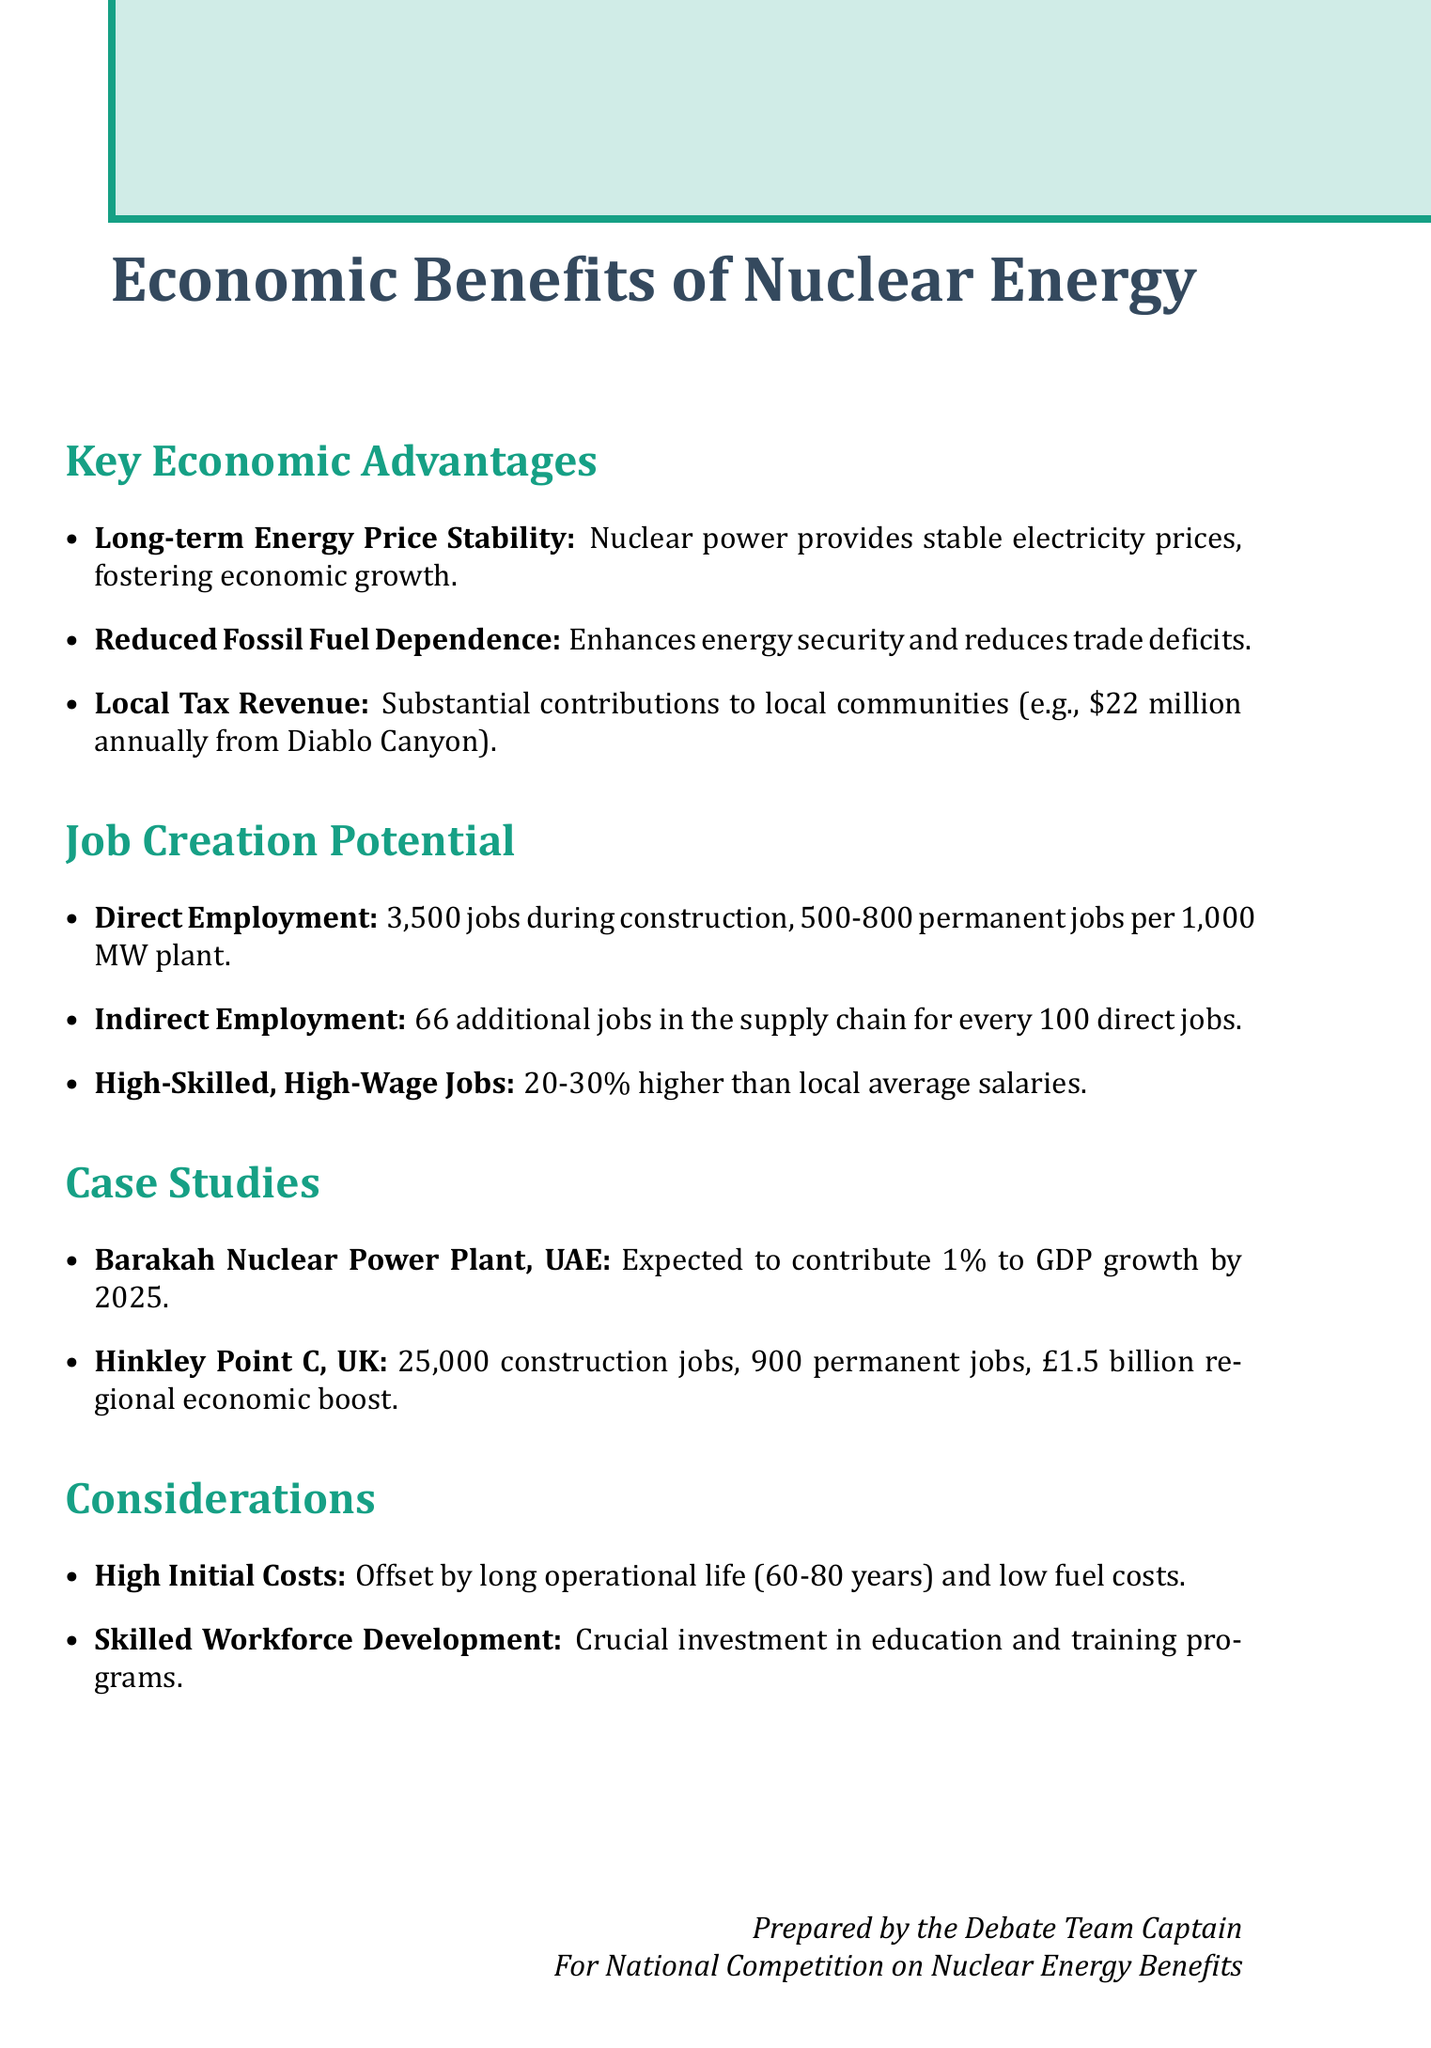What is the expected contribution of Barakah Nuclear Power Plant to UAE's GDP growth by 2025? The document states that the Barakah plant in the UAE is expected to contribute 1% to the country's GDP growth by 2025.
Answer: 1% How many jobs does a typical 1,000 MW nuclear power plant create during peak construction? According to the document, a typical 1,000 MW nuclear power plant creates about 3,500 jobs during peak construction.
Answer: 3,500 What is the annual tax revenue contribution of the Diablo Canyon Power Plant to San Luis Obispo County? The Diablo Canyon Power Plant contributes approximately $22 million annually in property taxes to San Luis Obispo County.
Answer: $22 million How many jobs are expected from the Hinkley Point C project during its construction period? The document states that the Hinkley Point C project is expected to create 25,000 job opportunities over its construction period.
Answer: 25,000 What percentage higher are nuclear industry job salaries compared to the local average? The document indicates that nuclear industry jobs typically have average salaries 20-30% higher than the local average.
Answer: 20-30% What is one challenge faced by nuclear power plant projects regarding financial investment? The document mentions that nuclear power plants have high upfront costs, which can be a barrier to investment.
Answer: High upfront costs What needs to be invested in to meet the employment needs of the nuclear sector? The document states that investments in education and training programs are crucial to meet the sector's employment needs.
Answer: Education and training programs For every 100 direct jobs in a nuclear plant, how many indirect jobs are created in the supply chain? The document says for every 100 direct jobs in a nuclear power plant, an additional 66 indirect jobs are created in the supply chain.
Answer: 66 What is the role of nuclear energy in reducing a country's dependence on fossil fuels? The document states that nuclear energy can significantly reduce a country's reliance on imported fossil fuels, improving energy security.
Answer: Reduce reliance on imported fossil fuels 